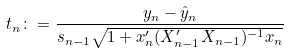Convert formula to latex. <formula><loc_0><loc_0><loc_500><loc_500>t _ { n } \colon = \frac { y _ { n } - \hat { y } _ { n } } { s _ { n - 1 } \sqrt { 1 + x _ { n } ^ { \prime } ( X _ { n - 1 } ^ { \prime } X _ { n - 1 } ) ^ { - 1 } x _ { n } } }</formula> 